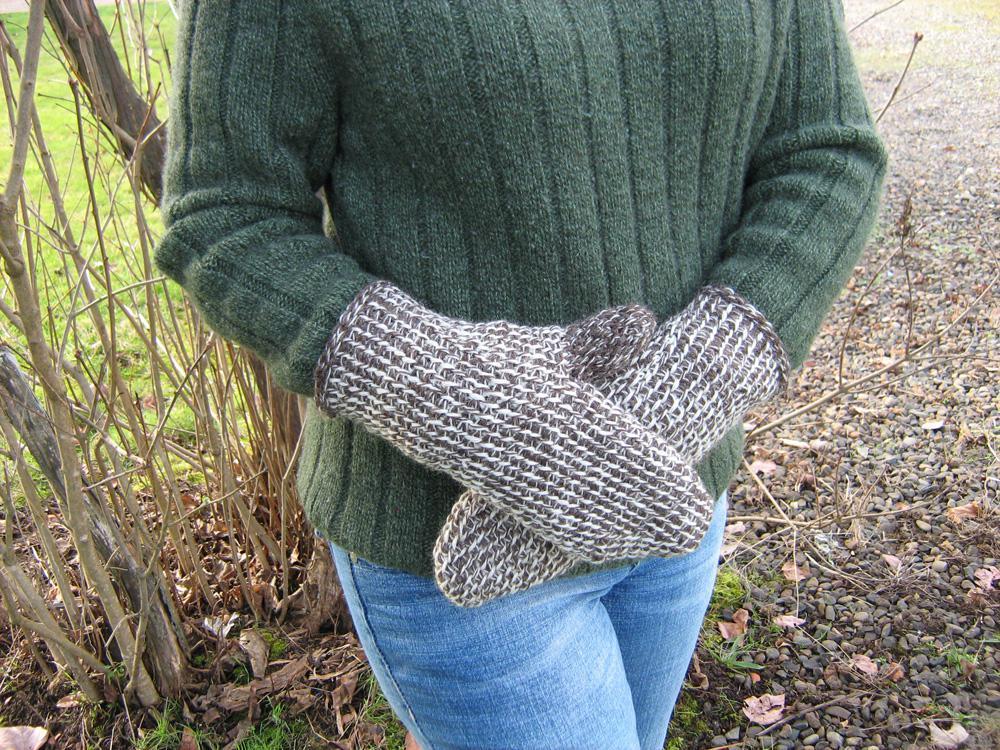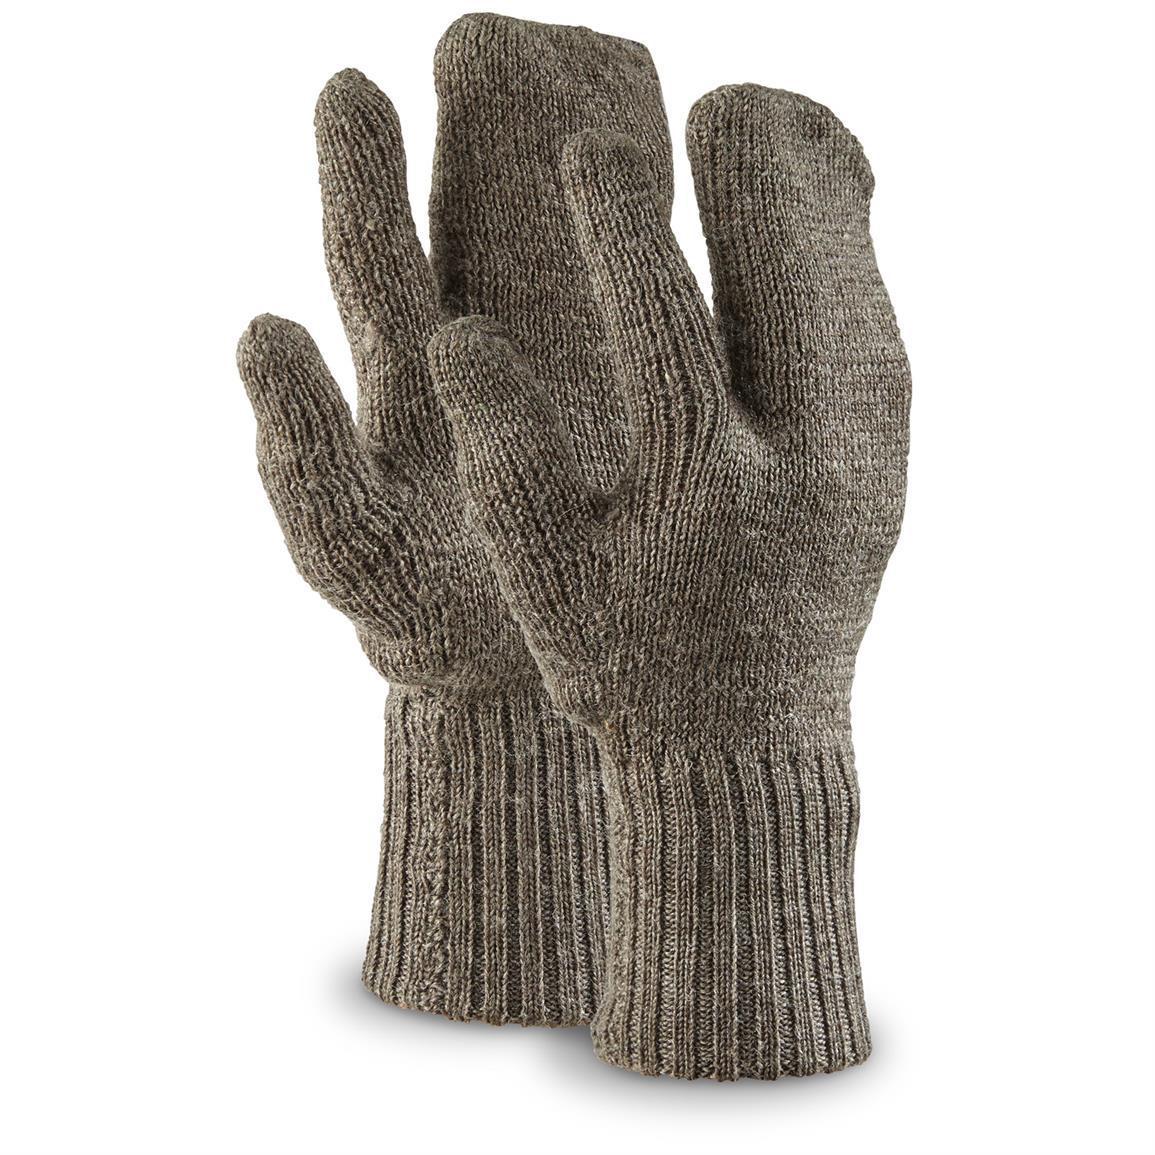The first image is the image on the left, the second image is the image on the right. Examine the images to the left and right. Is the description "An image includes a brown knitted hybrid of a mitten and a glove." accurate? Answer yes or no. Yes. 